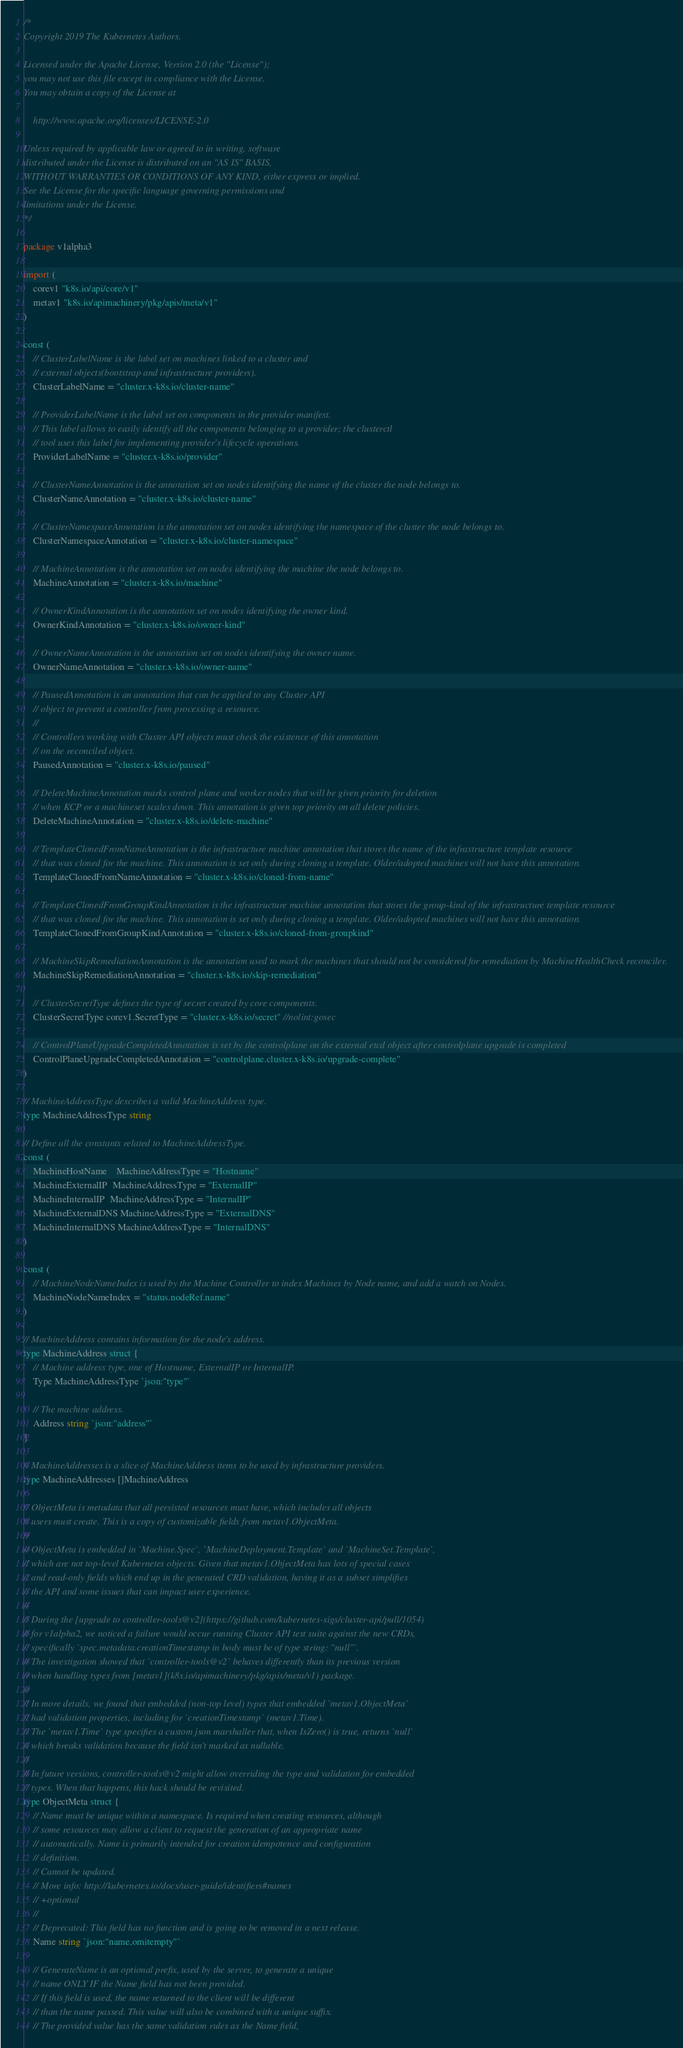<code> <loc_0><loc_0><loc_500><loc_500><_Go_>/*
Copyright 2019 The Kubernetes Authors.

Licensed under the Apache License, Version 2.0 (the "License");
you may not use this file except in compliance with the License.
You may obtain a copy of the License at

    http://www.apache.org/licenses/LICENSE-2.0

Unless required by applicable law or agreed to in writing, software
distributed under the License is distributed on an "AS IS" BASIS,
WITHOUT WARRANTIES OR CONDITIONS OF ANY KIND, either express or implied.
See the License for the specific language governing permissions and
limitations under the License.
*/

package v1alpha3

import (
	corev1 "k8s.io/api/core/v1"
	metav1 "k8s.io/apimachinery/pkg/apis/meta/v1"
)

const (
	// ClusterLabelName is the label set on machines linked to a cluster and
	// external objects(bootstrap and infrastructure providers).
	ClusterLabelName = "cluster.x-k8s.io/cluster-name"

	// ProviderLabelName is the label set on components in the provider manifest.
	// This label allows to easily identify all the components belonging to a provider; the clusterctl
	// tool uses this label for implementing provider's lifecycle operations.
	ProviderLabelName = "cluster.x-k8s.io/provider"

	// ClusterNameAnnotation is the annotation set on nodes identifying the name of the cluster the node belongs to.
	ClusterNameAnnotation = "cluster.x-k8s.io/cluster-name"

	// ClusterNamespaceAnnotation is the annotation set on nodes identifying the namespace of the cluster the node belongs to.
	ClusterNamespaceAnnotation = "cluster.x-k8s.io/cluster-namespace"

	// MachineAnnotation is the annotation set on nodes identifying the machine the node belongs to.
	MachineAnnotation = "cluster.x-k8s.io/machine"

	// OwnerKindAnnotation is the annotation set on nodes identifying the owner kind.
	OwnerKindAnnotation = "cluster.x-k8s.io/owner-kind"

	// OwnerNameAnnotation is the annotation set on nodes identifying the owner name.
	OwnerNameAnnotation = "cluster.x-k8s.io/owner-name"

	// PausedAnnotation is an annotation that can be applied to any Cluster API
	// object to prevent a controller from processing a resource.
	//
	// Controllers working with Cluster API objects must check the existence of this annotation
	// on the reconciled object.
	PausedAnnotation = "cluster.x-k8s.io/paused"

	// DeleteMachineAnnotation marks control plane and worker nodes that will be given priority for deletion
	// when KCP or a machineset scales down. This annotation is given top priority on all delete policies.
	DeleteMachineAnnotation = "cluster.x-k8s.io/delete-machine"

	// TemplateClonedFromNameAnnotation is the infrastructure machine annotation that stores the name of the infrastructure template resource
	// that was cloned for the machine. This annotation is set only during cloning a template. Older/adopted machines will not have this annotation.
	TemplateClonedFromNameAnnotation = "cluster.x-k8s.io/cloned-from-name"

	// TemplateClonedFromGroupKindAnnotation is the infrastructure machine annotation that stores the group-kind of the infrastructure template resource
	// that was cloned for the machine. This annotation is set only during cloning a template. Older/adopted machines will not have this annotation.
	TemplateClonedFromGroupKindAnnotation = "cluster.x-k8s.io/cloned-from-groupkind"

	// MachineSkipRemediationAnnotation is the annotation used to mark the machines that should not be considered for remediation by MachineHealthCheck reconciler.
	MachineSkipRemediationAnnotation = "cluster.x-k8s.io/skip-remediation"

	// ClusterSecretType defines the type of secret created by core components.
	ClusterSecretType corev1.SecretType = "cluster.x-k8s.io/secret" //nolint:gosec

	// ControlPlaneUpgradeCompletedAnnotation is set by the controlplane on the external etcd object after controlplane upgrade is completed
	ControlPlaneUpgradeCompletedAnnotation = "controlplane.cluster.x-k8s.io/upgrade-complete"
)

// MachineAddressType describes a valid MachineAddress type.
type MachineAddressType string

// Define all the constants related to MachineAddressType.
const (
	MachineHostName    MachineAddressType = "Hostname"
	MachineExternalIP  MachineAddressType = "ExternalIP"
	MachineInternalIP  MachineAddressType = "InternalIP"
	MachineExternalDNS MachineAddressType = "ExternalDNS"
	MachineInternalDNS MachineAddressType = "InternalDNS"
)

const (
	// MachineNodeNameIndex is used by the Machine Controller to index Machines by Node name, and add a watch on Nodes.
	MachineNodeNameIndex = "status.nodeRef.name"
)

// MachineAddress contains information for the node's address.
type MachineAddress struct {
	// Machine address type, one of Hostname, ExternalIP or InternalIP.
	Type MachineAddressType `json:"type"`

	// The machine address.
	Address string `json:"address"`
}

// MachineAddresses is a slice of MachineAddress items to be used by infrastructure providers.
type MachineAddresses []MachineAddress

// ObjectMeta is metadata that all persisted resources must have, which includes all objects
// users must create. This is a copy of customizable fields from metav1.ObjectMeta.
//
// ObjectMeta is embedded in `Machine.Spec`, `MachineDeployment.Template` and `MachineSet.Template`,
// which are not top-level Kubernetes objects. Given that metav1.ObjectMeta has lots of special cases
// and read-only fields which end up in the generated CRD validation, having it as a subset simplifies
// the API and some issues that can impact user experience.
//
// During the [upgrade to controller-tools@v2](https://github.com/kubernetes-sigs/cluster-api/pull/1054)
// for v1alpha2, we noticed a failure would occur running Cluster API test suite against the new CRDs,
// specifically `spec.metadata.creationTimestamp in body must be of type string: "null"`.
// The investigation showed that `controller-tools@v2` behaves differently than its previous version
// when handling types from [metav1](k8s.io/apimachinery/pkg/apis/meta/v1) package.
//
// In more details, we found that embedded (non-top level) types that embedded `metav1.ObjectMeta`
// had validation properties, including for `creationTimestamp` (metav1.Time).
// The `metav1.Time` type specifies a custom json marshaller that, when IsZero() is true, returns `null`
// which breaks validation because the field isn't marked as nullable.
//
// In future versions, controller-tools@v2 might allow overriding the type and validation for embedded
// types. When that happens, this hack should be revisited.
type ObjectMeta struct {
	// Name must be unique within a namespace. Is required when creating resources, although
	// some resources may allow a client to request the generation of an appropriate name
	// automatically. Name is primarily intended for creation idempotence and configuration
	// definition.
	// Cannot be updated.
	// More info: http://kubernetes.io/docs/user-guide/identifiers#names
	// +optional
	//
	// Deprecated: This field has no function and is going to be removed in a next release.
	Name string `json:"name,omitempty"`

	// GenerateName is an optional prefix, used by the server, to generate a unique
	// name ONLY IF the Name field has not been provided.
	// If this field is used, the name returned to the client will be different
	// than the name passed. This value will also be combined with a unique suffix.
	// The provided value has the same validation rules as the Name field,</code> 